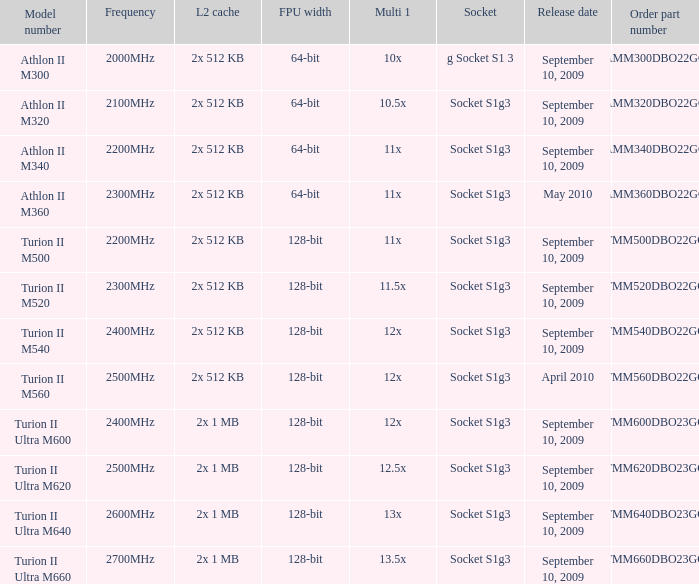What is the L2 cache with a 13.5x multi 1? 2x 1 MB. 